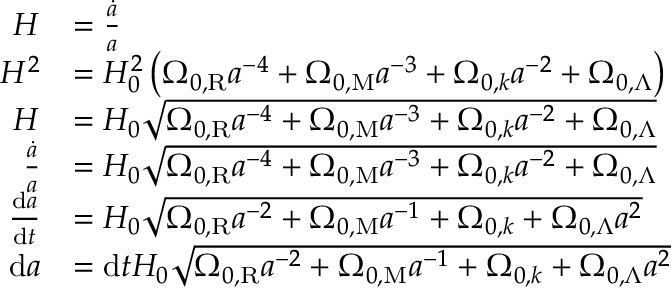Convert formula to latex. <formula><loc_0><loc_0><loc_500><loc_500>{ \begin{array} { r l } { H } & { = { \frac { \dot { a } } { a } } } \\ { H ^ { 2 } } & { = H _ { 0 } ^ { 2 } \left ( \Omega _ { 0 , R } a ^ { - 4 } + \Omega _ { 0 , M } a ^ { - 3 } + \Omega _ { 0 , k } a ^ { - 2 } + \Omega _ { 0 , \Lambda } \right ) } \\ { H } & { = H _ { 0 } { \sqrt { \Omega _ { 0 , R } a ^ { - 4 } + \Omega _ { 0 , M } a ^ { - 3 } + \Omega _ { 0 , k } a ^ { - 2 } + \Omega _ { 0 , \Lambda } } } } \\ { { \frac { \dot { a } } { a } } } & { = H _ { 0 } { \sqrt { \Omega _ { 0 , R } a ^ { - 4 } + \Omega _ { 0 , M } a ^ { - 3 } + \Omega _ { 0 , k } a ^ { - 2 } + \Omega _ { 0 , \Lambda } } } } \\ { { \frac { d a } { d t } } } & { = H _ { 0 } { \sqrt { \Omega _ { 0 , R } a ^ { - 2 } + \Omega _ { 0 , M } a ^ { - 1 } + \Omega _ { 0 , k } + \Omega _ { 0 , \Lambda } a ^ { 2 } } } } \\ { d a } & { = d t H _ { 0 } { \sqrt { \Omega _ { 0 , R } a ^ { - 2 } + \Omega _ { 0 , M } a ^ { - 1 } + \Omega _ { 0 , k } + \Omega _ { 0 , \Lambda } a ^ { 2 } } } } \end{array} }</formula> 